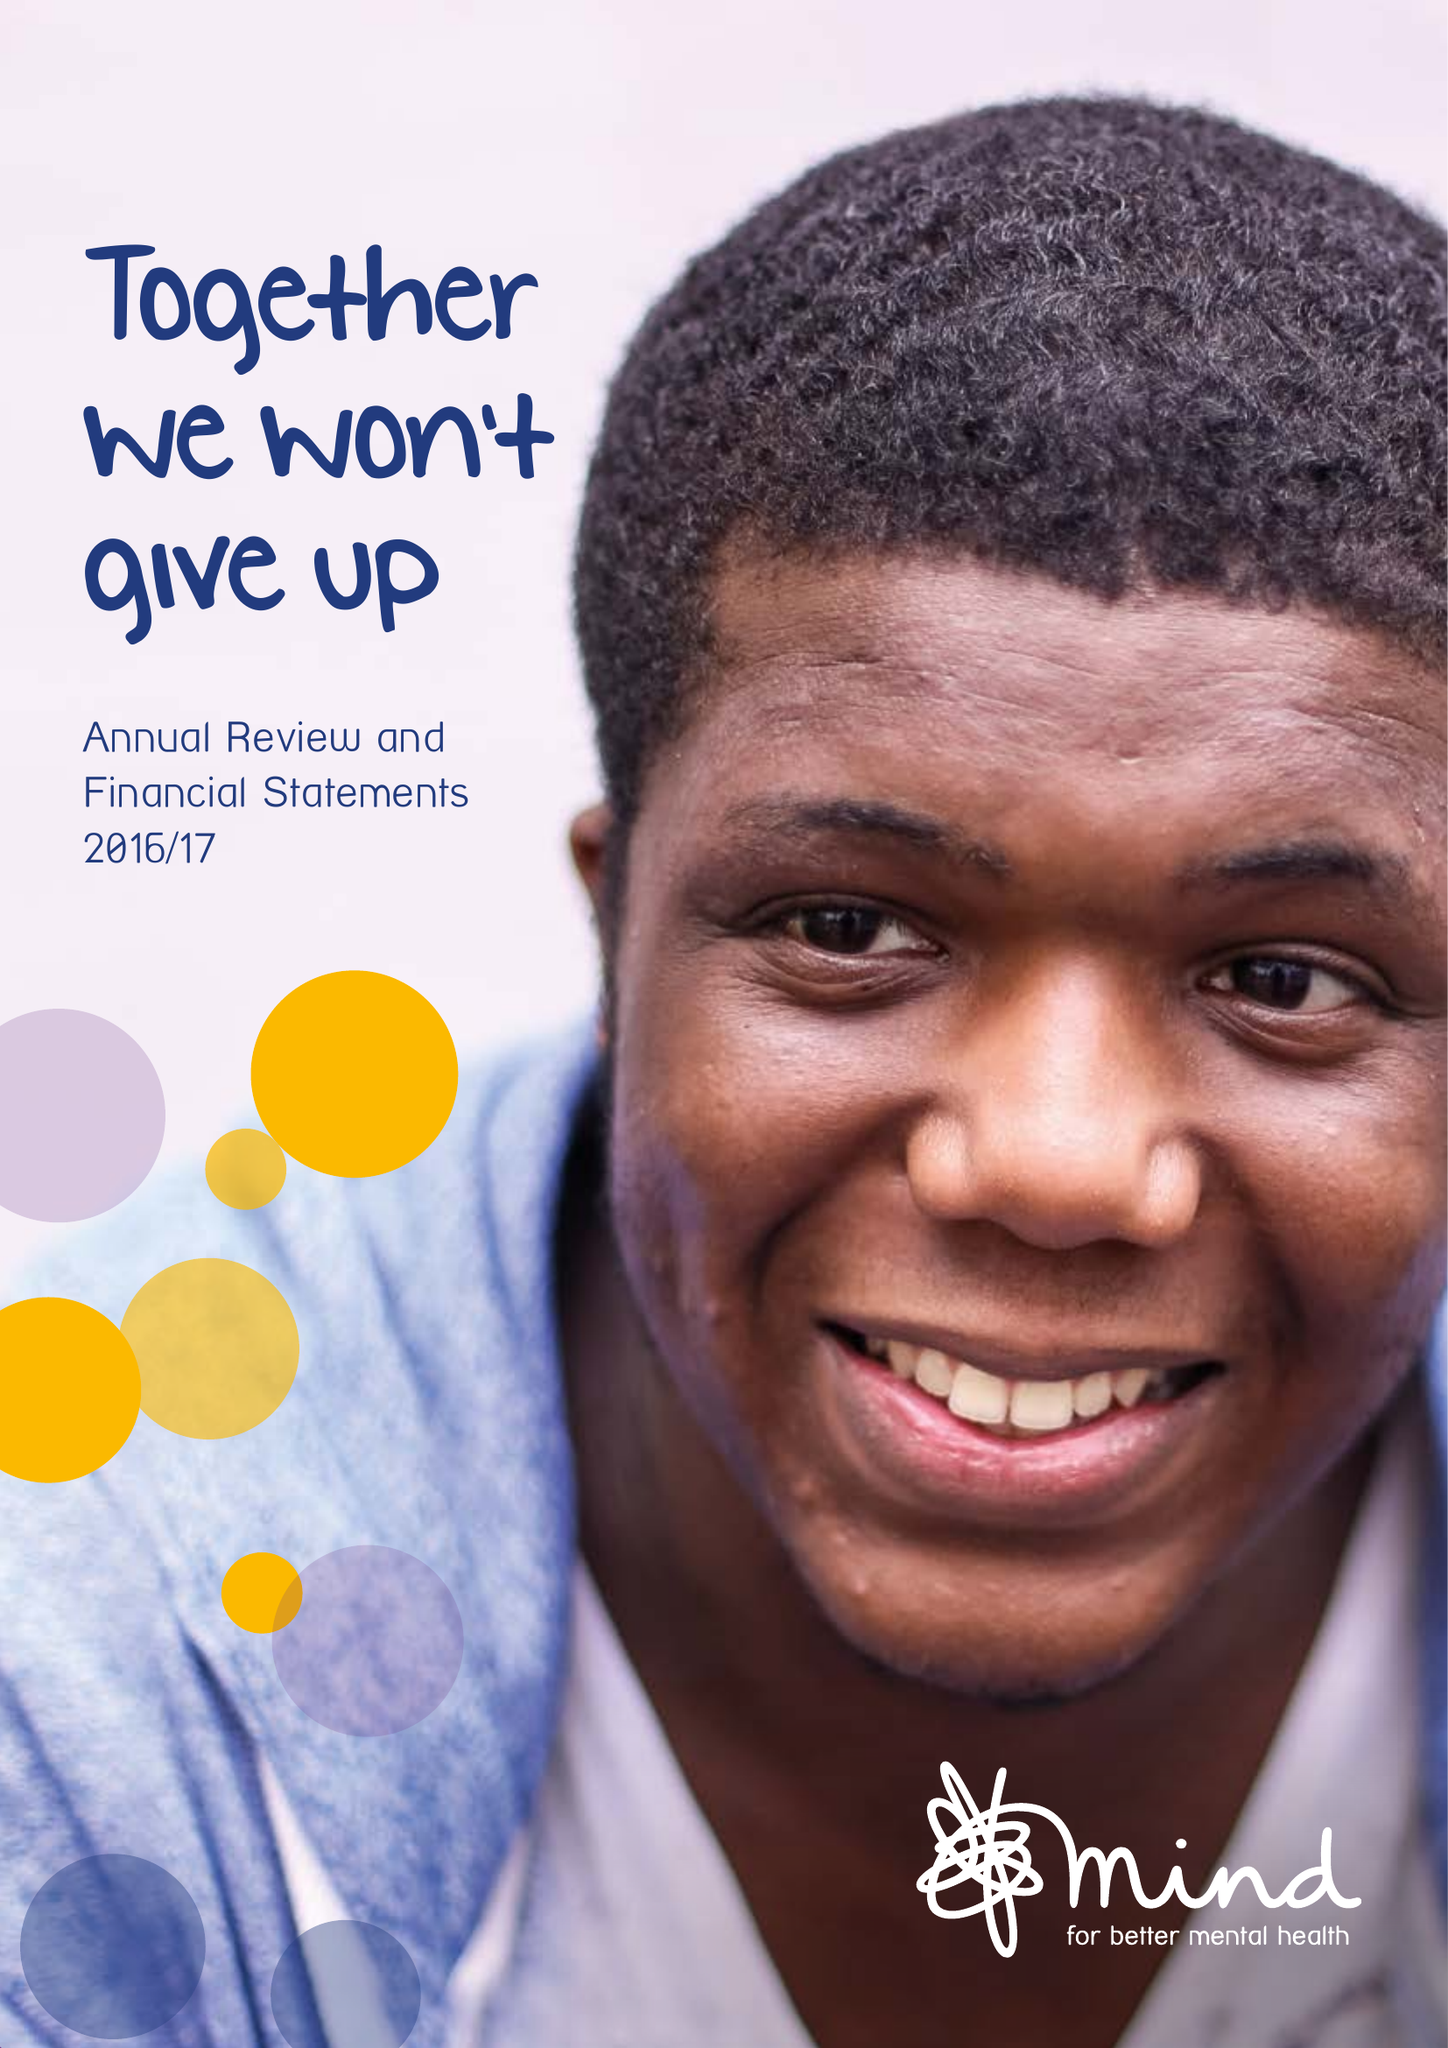What is the value for the charity_name?
Answer the question using a single word or phrase. Mind (The NA 